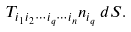<formula> <loc_0><loc_0><loc_500><loc_500>T _ { i _ { 1 } i _ { 2 } \cdots i _ { q } \cdots i _ { n } } n _ { i _ { q } } \, d S .</formula> 